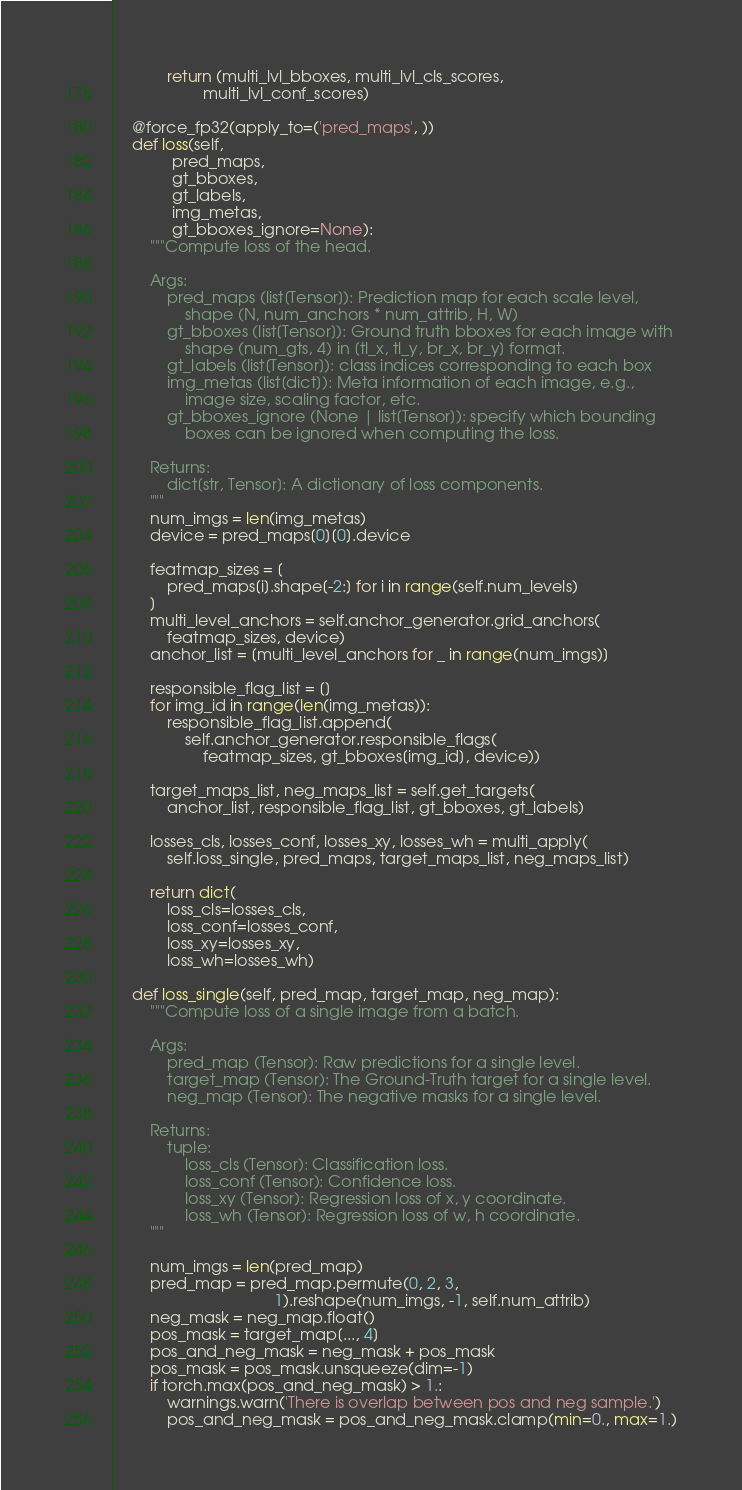<code> <loc_0><loc_0><loc_500><loc_500><_Python_>            return (multi_lvl_bboxes, multi_lvl_cls_scores,
                    multi_lvl_conf_scores)

    @force_fp32(apply_to=('pred_maps', ))
    def loss(self,
             pred_maps,
             gt_bboxes,
             gt_labels,
             img_metas,
             gt_bboxes_ignore=None):
        """Compute loss of the head.

        Args:
            pred_maps (list[Tensor]): Prediction map for each scale level,
                shape (N, num_anchors * num_attrib, H, W)
            gt_bboxes (list[Tensor]): Ground truth bboxes for each image with
                shape (num_gts, 4) in [tl_x, tl_y, br_x, br_y] format.
            gt_labels (list[Tensor]): class indices corresponding to each box
            img_metas (list[dict]): Meta information of each image, e.g.,
                image size, scaling factor, etc.
            gt_bboxes_ignore (None | list[Tensor]): specify which bounding
                boxes can be ignored when computing the loss.

        Returns:
            dict[str, Tensor]: A dictionary of loss components.
        """
        num_imgs = len(img_metas)
        device = pred_maps[0][0].device

        featmap_sizes = [
            pred_maps[i].shape[-2:] for i in range(self.num_levels)
        ]
        multi_level_anchors = self.anchor_generator.grid_anchors(
            featmap_sizes, device)
        anchor_list = [multi_level_anchors for _ in range(num_imgs)]

        responsible_flag_list = []
        for img_id in range(len(img_metas)):
            responsible_flag_list.append(
                self.anchor_generator.responsible_flags(
                    featmap_sizes, gt_bboxes[img_id], device))

        target_maps_list, neg_maps_list = self.get_targets(
            anchor_list, responsible_flag_list, gt_bboxes, gt_labels)

        losses_cls, losses_conf, losses_xy, losses_wh = multi_apply(
            self.loss_single, pred_maps, target_maps_list, neg_maps_list)

        return dict(
            loss_cls=losses_cls,
            loss_conf=losses_conf,
            loss_xy=losses_xy,
            loss_wh=losses_wh)

    def loss_single(self, pred_map, target_map, neg_map):
        """Compute loss of a single image from a batch.

        Args:
            pred_map (Tensor): Raw predictions for a single level.
            target_map (Tensor): The Ground-Truth target for a single level.
            neg_map (Tensor): The negative masks for a single level.

        Returns:
            tuple:
                loss_cls (Tensor): Classification loss.
                loss_conf (Tensor): Confidence loss.
                loss_xy (Tensor): Regression loss of x, y coordinate.
                loss_wh (Tensor): Regression loss of w, h coordinate.
        """

        num_imgs = len(pred_map)
        pred_map = pred_map.permute(0, 2, 3,
                                    1).reshape(num_imgs, -1, self.num_attrib)
        neg_mask = neg_map.float()
        pos_mask = target_map[..., 4]
        pos_and_neg_mask = neg_mask + pos_mask
        pos_mask = pos_mask.unsqueeze(dim=-1)
        if torch.max(pos_and_neg_mask) > 1.:
            warnings.warn('There is overlap between pos and neg sample.')
            pos_and_neg_mask = pos_and_neg_mask.clamp(min=0., max=1.)
</code> 